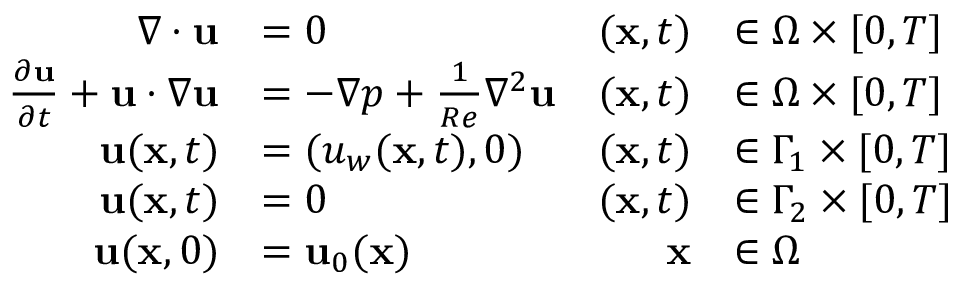<formula> <loc_0><loc_0><loc_500><loc_500>\begin{array} { r l r l } { \nabla \cdot { u } } & { = 0 } & { ( x , t ) } & { \in \Omega \times [ 0 , T ] } \\ { \frac { \partial u } { \partial t } + { u } \cdot \nabla { u } } & { = - \nabla p + \frac { 1 } { R e } { \nabla ^ { 2 } } { u } } & { ( x , t ) } & { \in \Omega \times [ 0 , T ] } \\ { u ( x , t ) } & { = ( u _ { w } ( x , t ) , 0 ) } & { ( x , t ) } & { \in \Gamma _ { 1 } \times [ 0 , T ] } \\ { u ( x , t ) } & { = 0 } & { ( x , t ) } & { \in \Gamma _ { 2 } \times [ 0 , T ] } \\ { u ( x , 0 ) } & { = u _ { 0 } ( x ) } & { x } & { \in \Omega } \end{array}</formula> 